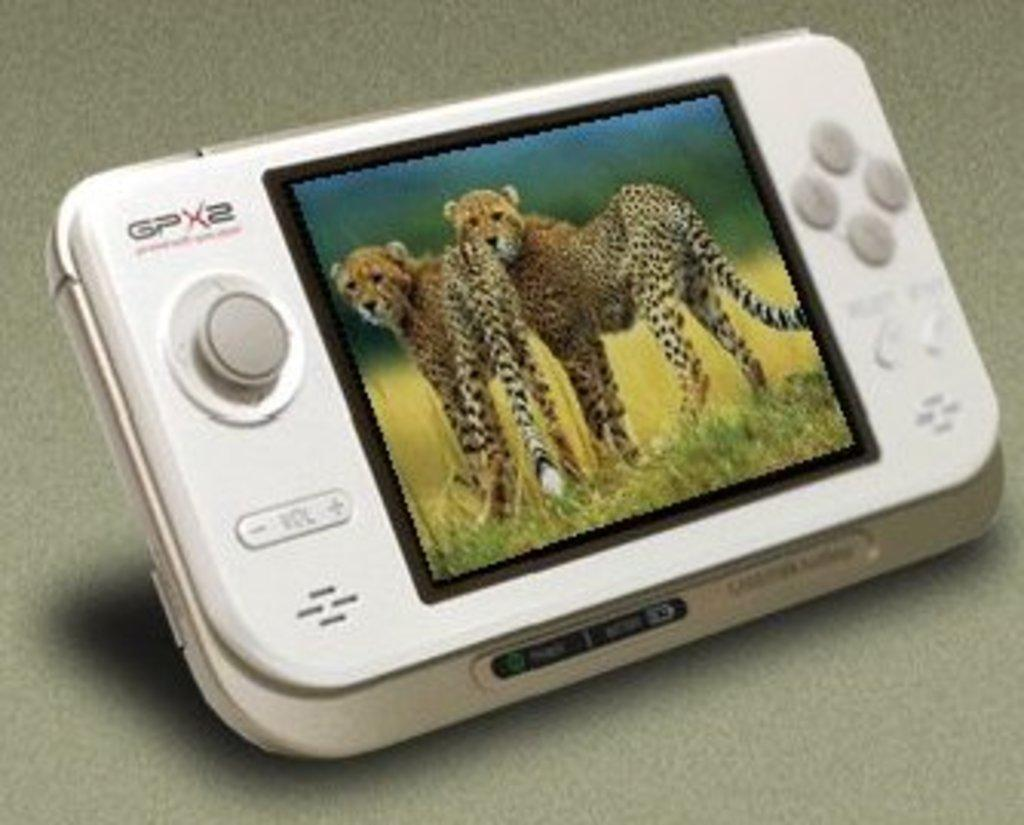What type of video game is in the image? There is a joystick video game in the image. Where is the video game located in the image? The joystick video game is in the middle of the image. What type of nut is being used to fuel the fire in the image? There is no nut or fire present in the image; it features a joystick video game. What type of battle is taking place in the image? There is no battle present in the image; it features a joystick video game. 